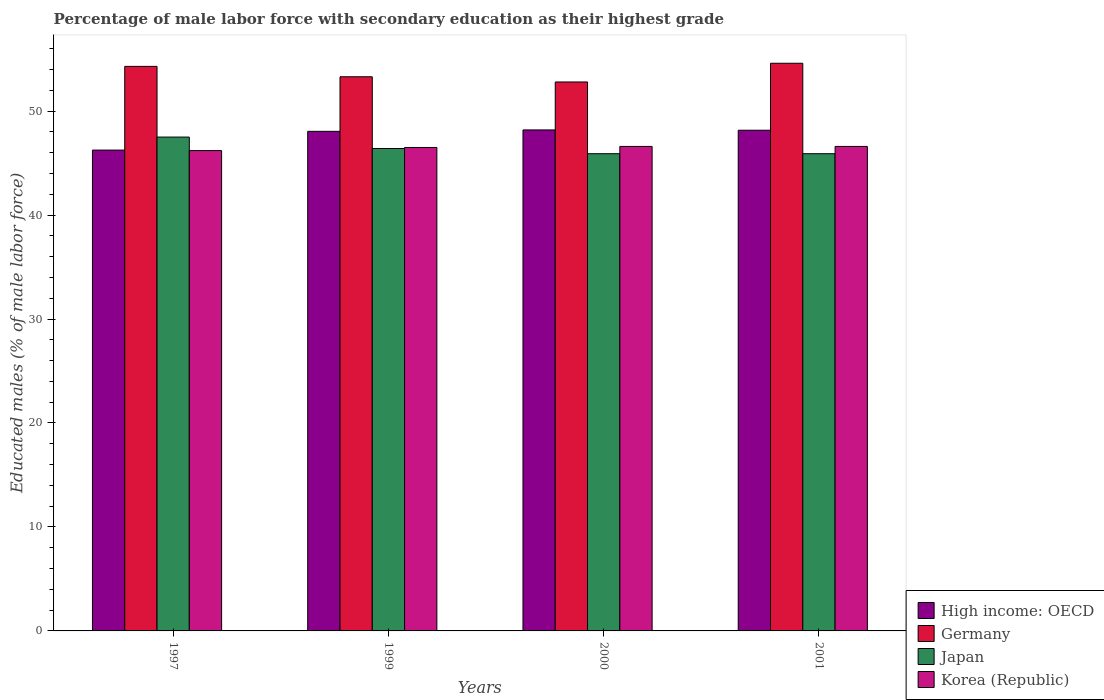How many groups of bars are there?
Your response must be concise. 4. How many bars are there on the 4th tick from the right?
Ensure brevity in your answer.  4. What is the label of the 3rd group of bars from the left?
Provide a succinct answer. 2000. What is the percentage of male labor force with secondary education in High income: OECD in 1999?
Give a very brief answer. 48.05. Across all years, what is the maximum percentage of male labor force with secondary education in Japan?
Offer a terse response. 47.5. Across all years, what is the minimum percentage of male labor force with secondary education in Germany?
Your response must be concise. 52.8. In which year was the percentage of male labor force with secondary education in Japan minimum?
Keep it short and to the point. 2000. What is the total percentage of male labor force with secondary education in High income: OECD in the graph?
Ensure brevity in your answer.  190.65. What is the difference between the percentage of male labor force with secondary education in Korea (Republic) in 1997 and that in 1999?
Give a very brief answer. -0.3. What is the difference between the percentage of male labor force with secondary education in High income: OECD in 2000 and the percentage of male labor force with secondary education in Korea (Republic) in 1999?
Keep it short and to the point. 1.69. What is the average percentage of male labor force with secondary education in Korea (Republic) per year?
Offer a very short reply. 46.47. In the year 2001, what is the difference between the percentage of male labor force with secondary education in Korea (Republic) and percentage of male labor force with secondary education in Japan?
Offer a very short reply. 0.7. What is the ratio of the percentage of male labor force with secondary education in Japan in 1999 to that in 2001?
Keep it short and to the point. 1.01. Is the percentage of male labor force with secondary education in Korea (Republic) in 1997 less than that in 2001?
Provide a succinct answer. Yes. What is the difference between the highest and the second highest percentage of male labor force with secondary education in Japan?
Make the answer very short. 1.1. What is the difference between the highest and the lowest percentage of male labor force with secondary education in Germany?
Your response must be concise. 1.8. Is the sum of the percentage of male labor force with secondary education in Germany in 1997 and 1999 greater than the maximum percentage of male labor force with secondary education in Korea (Republic) across all years?
Keep it short and to the point. Yes. Is it the case that in every year, the sum of the percentage of male labor force with secondary education in High income: OECD and percentage of male labor force with secondary education in Germany is greater than the sum of percentage of male labor force with secondary education in Korea (Republic) and percentage of male labor force with secondary education in Japan?
Give a very brief answer. Yes. What does the 2nd bar from the right in 1999 represents?
Offer a terse response. Japan. How many bars are there?
Ensure brevity in your answer.  16. Are all the bars in the graph horizontal?
Make the answer very short. No. What is the difference between two consecutive major ticks on the Y-axis?
Make the answer very short. 10. Are the values on the major ticks of Y-axis written in scientific E-notation?
Provide a succinct answer. No. Does the graph contain any zero values?
Give a very brief answer. No. Does the graph contain grids?
Your response must be concise. No. Where does the legend appear in the graph?
Ensure brevity in your answer.  Bottom right. How many legend labels are there?
Keep it short and to the point. 4. What is the title of the graph?
Make the answer very short. Percentage of male labor force with secondary education as their highest grade. Does "Kosovo" appear as one of the legend labels in the graph?
Keep it short and to the point. No. What is the label or title of the X-axis?
Your answer should be very brief. Years. What is the label or title of the Y-axis?
Give a very brief answer. Educated males (% of male labor force). What is the Educated males (% of male labor force) in High income: OECD in 1997?
Your answer should be very brief. 46.25. What is the Educated males (% of male labor force) of Germany in 1997?
Your answer should be compact. 54.3. What is the Educated males (% of male labor force) in Japan in 1997?
Ensure brevity in your answer.  47.5. What is the Educated males (% of male labor force) of Korea (Republic) in 1997?
Your answer should be very brief. 46.2. What is the Educated males (% of male labor force) of High income: OECD in 1999?
Ensure brevity in your answer.  48.05. What is the Educated males (% of male labor force) of Germany in 1999?
Provide a succinct answer. 53.3. What is the Educated males (% of male labor force) in Japan in 1999?
Your answer should be very brief. 46.4. What is the Educated males (% of male labor force) of Korea (Republic) in 1999?
Your answer should be very brief. 46.5. What is the Educated males (% of male labor force) in High income: OECD in 2000?
Offer a very short reply. 48.19. What is the Educated males (% of male labor force) in Germany in 2000?
Give a very brief answer. 52.8. What is the Educated males (% of male labor force) of Japan in 2000?
Provide a succinct answer. 45.9. What is the Educated males (% of male labor force) in Korea (Republic) in 2000?
Provide a succinct answer. 46.6. What is the Educated males (% of male labor force) of High income: OECD in 2001?
Make the answer very short. 48.16. What is the Educated males (% of male labor force) of Germany in 2001?
Make the answer very short. 54.6. What is the Educated males (% of male labor force) of Japan in 2001?
Keep it short and to the point. 45.9. What is the Educated males (% of male labor force) in Korea (Republic) in 2001?
Offer a terse response. 46.6. Across all years, what is the maximum Educated males (% of male labor force) in High income: OECD?
Provide a short and direct response. 48.19. Across all years, what is the maximum Educated males (% of male labor force) of Germany?
Your answer should be very brief. 54.6. Across all years, what is the maximum Educated males (% of male labor force) in Japan?
Keep it short and to the point. 47.5. Across all years, what is the maximum Educated males (% of male labor force) in Korea (Republic)?
Provide a short and direct response. 46.6. Across all years, what is the minimum Educated males (% of male labor force) in High income: OECD?
Your answer should be compact. 46.25. Across all years, what is the minimum Educated males (% of male labor force) in Germany?
Your answer should be compact. 52.8. Across all years, what is the minimum Educated males (% of male labor force) in Japan?
Ensure brevity in your answer.  45.9. Across all years, what is the minimum Educated males (% of male labor force) of Korea (Republic)?
Your answer should be very brief. 46.2. What is the total Educated males (% of male labor force) of High income: OECD in the graph?
Ensure brevity in your answer.  190.65. What is the total Educated males (% of male labor force) of Germany in the graph?
Keep it short and to the point. 215. What is the total Educated males (% of male labor force) in Japan in the graph?
Your answer should be very brief. 185.7. What is the total Educated males (% of male labor force) of Korea (Republic) in the graph?
Your answer should be very brief. 185.9. What is the difference between the Educated males (% of male labor force) of High income: OECD in 1997 and that in 1999?
Offer a terse response. -1.8. What is the difference between the Educated males (% of male labor force) of Japan in 1997 and that in 1999?
Give a very brief answer. 1.1. What is the difference between the Educated males (% of male labor force) of Korea (Republic) in 1997 and that in 1999?
Your response must be concise. -0.3. What is the difference between the Educated males (% of male labor force) of High income: OECD in 1997 and that in 2000?
Your answer should be very brief. -1.94. What is the difference between the Educated males (% of male labor force) of Korea (Republic) in 1997 and that in 2000?
Give a very brief answer. -0.4. What is the difference between the Educated males (% of male labor force) in High income: OECD in 1997 and that in 2001?
Make the answer very short. -1.91. What is the difference between the Educated males (% of male labor force) in Japan in 1997 and that in 2001?
Provide a short and direct response. 1.6. What is the difference between the Educated males (% of male labor force) in Korea (Republic) in 1997 and that in 2001?
Offer a terse response. -0.4. What is the difference between the Educated males (% of male labor force) in High income: OECD in 1999 and that in 2000?
Your answer should be very brief. -0.14. What is the difference between the Educated males (% of male labor force) of High income: OECD in 1999 and that in 2001?
Your answer should be very brief. -0.11. What is the difference between the Educated males (% of male labor force) in High income: OECD in 2000 and that in 2001?
Ensure brevity in your answer.  0.03. What is the difference between the Educated males (% of male labor force) of Germany in 2000 and that in 2001?
Ensure brevity in your answer.  -1.8. What is the difference between the Educated males (% of male labor force) of High income: OECD in 1997 and the Educated males (% of male labor force) of Germany in 1999?
Your answer should be very brief. -7.05. What is the difference between the Educated males (% of male labor force) in High income: OECD in 1997 and the Educated males (% of male labor force) in Japan in 1999?
Keep it short and to the point. -0.15. What is the difference between the Educated males (% of male labor force) in High income: OECD in 1997 and the Educated males (% of male labor force) in Korea (Republic) in 1999?
Your response must be concise. -0.25. What is the difference between the Educated males (% of male labor force) in Germany in 1997 and the Educated males (% of male labor force) in Korea (Republic) in 1999?
Ensure brevity in your answer.  7.8. What is the difference between the Educated males (% of male labor force) in Japan in 1997 and the Educated males (% of male labor force) in Korea (Republic) in 1999?
Make the answer very short. 1. What is the difference between the Educated males (% of male labor force) in High income: OECD in 1997 and the Educated males (% of male labor force) in Germany in 2000?
Your response must be concise. -6.55. What is the difference between the Educated males (% of male labor force) of High income: OECD in 1997 and the Educated males (% of male labor force) of Japan in 2000?
Your response must be concise. 0.35. What is the difference between the Educated males (% of male labor force) of High income: OECD in 1997 and the Educated males (% of male labor force) of Korea (Republic) in 2000?
Offer a terse response. -0.35. What is the difference between the Educated males (% of male labor force) in Germany in 1997 and the Educated males (% of male labor force) in Japan in 2000?
Provide a succinct answer. 8.4. What is the difference between the Educated males (% of male labor force) in Japan in 1997 and the Educated males (% of male labor force) in Korea (Republic) in 2000?
Your response must be concise. 0.9. What is the difference between the Educated males (% of male labor force) of High income: OECD in 1997 and the Educated males (% of male labor force) of Germany in 2001?
Keep it short and to the point. -8.35. What is the difference between the Educated males (% of male labor force) of High income: OECD in 1997 and the Educated males (% of male labor force) of Japan in 2001?
Provide a short and direct response. 0.35. What is the difference between the Educated males (% of male labor force) of High income: OECD in 1997 and the Educated males (% of male labor force) of Korea (Republic) in 2001?
Your answer should be compact. -0.35. What is the difference between the Educated males (% of male labor force) of Germany in 1997 and the Educated males (% of male labor force) of Korea (Republic) in 2001?
Provide a short and direct response. 7.7. What is the difference between the Educated males (% of male labor force) in Japan in 1997 and the Educated males (% of male labor force) in Korea (Republic) in 2001?
Make the answer very short. 0.9. What is the difference between the Educated males (% of male labor force) in High income: OECD in 1999 and the Educated males (% of male labor force) in Germany in 2000?
Offer a very short reply. -4.75. What is the difference between the Educated males (% of male labor force) in High income: OECD in 1999 and the Educated males (% of male labor force) in Japan in 2000?
Keep it short and to the point. 2.15. What is the difference between the Educated males (% of male labor force) of High income: OECD in 1999 and the Educated males (% of male labor force) of Korea (Republic) in 2000?
Offer a terse response. 1.45. What is the difference between the Educated males (% of male labor force) in High income: OECD in 1999 and the Educated males (% of male labor force) in Germany in 2001?
Give a very brief answer. -6.55. What is the difference between the Educated males (% of male labor force) in High income: OECD in 1999 and the Educated males (% of male labor force) in Japan in 2001?
Your answer should be compact. 2.15. What is the difference between the Educated males (% of male labor force) in High income: OECD in 1999 and the Educated males (% of male labor force) in Korea (Republic) in 2001?
Your answer should be very brief. 1.45. What is the difference between the Educated males (% of male labor force) of Germany in 1999 and the Educated males (% of male labor force) of Japan in 2001?
Offer a terse response. 7.4. What is the difference between the Educated males (% of male labor force) of Germany in 1999 and the Educated males (% of male labor force) of Korea (Republic) in 2001?
Give a very brief answer. 6.7. What is the difference between the Educated males (% of male labor force) in Japan in 1999 and the Educated males (% of male labor force) in Korea (Republic) in 2001?
Offer a terse response. -0.2. What is the difference between the Educated males (% of male labor force) of High income: OECD in 2000 and the Educated males (% of male labor force) of Germany in 2001?
Offer a very short reply. -6.41. What is the difference between the Educated males (% of male labor force) in High income: OECD in 2000 and the Educated males (% of male labor force) in Japan in 2001?
Ensure brevity in your answer.  2.29. What is the difference between the Educated males (% of male labor force) in High income: OECD in 2000 and the Educated males (% of male labor force) in Korea (Republic) in 2001?
Give a very brief answer. 1.59. What is the difference between the Educated males (% of male labor force) in Germany in 2000 and the Educated males (% of male labor force) in Korea (Republic) in 2001?
Make the answer very short. 6.2. What is the difference between the Educated males (% of male labor force) of Japan in 2000 and the Educated males (% of male labor force) of Korea (Republic) in 2001?
Ensure brevity in your answer.  -0.7. What is the average Educated males (% of male labor force) in High income: OECD per year?
Give a very brief answer. 47.66. What is the average Educated males (% of male labor force) in Germany per year?
Make the answer very short. 53.75. What is the average Educated males (% of male labor force) in Japan per year?
Make the answer very short. 46.42. What is the average Educated males (% of male labor force) of Korea (Republic) per year?
Ensure brevity in your answer.  46.48. In the year 1997, what is the difference between the Educated males (% of male labor force) of High income: OECD and Educated males (% of male labor force) of Germany?
Provide a short and direct response. -8.05. In the year 1997, what is the difference between the Educated males (% of male labor force) in High income: OECD and Educated males (% of male labor force) in Japan?
Provide a succinct answer. -1.25. In the year 1997, what is the difference between the Educated males (% of male labor force) in High income: OECD and Educated males (% of male labor force) in Korea (Republic)?
Your response must be concise. 0.05. In the year 1999, what is the difference between the Educated males (% of male labor force) in High income: OECD and Educated males (% of male labor force) in Germany?
Give a very brief answer. -5.25. In the year 1999, what is the difference between the Educated males (% of male labor force) in High income: OECD and Educated males (% of male labor force) in Japan?
Your response must be concise. 1.65. In the year 1999, what is the difference between the Educated males (% of male labor force) of High income: OECD and Educated males (% of male labor force) of Korea (Republic)?
Give a very brief answer. 1.55. In the year 2000, what is the difference between the Educated males (% of male labor force) of High income: OECD and Educated males (% of male labor force) of Germany?
Make the answer very short. -4.61. In the year 2000, what is the difference between the Educated males (% of male labor force) of High income: OECD and Educated males (% of male labor force) of Japan?
Provide a short and direct response. 2.29. In the year 2000, what is the difference between the Educated males (% of male labor force) of High income: OECD and Educated males (% of male labor force) of Korea (Republic)?
Your answer should be compact. 1.59. In the year 2000, what is the difference between the Educated males (% of male labor force) of Germany and Educated males (% of male labor force) of Korea (Republic)?
Provide a succinct answer. 6.2. In the year 2000, what is the difference between the Educated males (% of male labor force) of Japan and Educated males (% of male labor force) of Korea (Republic)?
Give a very brief answer. -0.7. In the year 2001, what is the difference between the Educated males (% of male labor force) in High income: OECD and Educated males (% of male labor force) in Germany?
Offer a terse response. -6.44. In the year 2001, what is the difference between the Educated males (% of male labor force) in High income: OECD and Educated males (% of male labor force) in Japan?
Offer a terse response. 2.26. In the year 2001, what is the difference between the Educated males (% of male labor force) of High income: OECD and Educated males (% of male labor force) of Korea (Republic)?
Ensure brevity in your answer.  1.56. In the year 2001, what is the difference between the Educated males (% of male labor force) of Germany and Educated males (% of male labor force) of Japan?
Offer a terse response. 8.7. In the year 2001, what is the difference between the Educated males (% of male labor force) of Japan and Educated males (% of male labor force) of Korea (Republic)?
Give a very brief answer. -0.7. What is the ratio of the Educated males (% of male labor force) in High income: OECD in 1997 to that in 1999?
Offer a terse response. 0.96. What is the ratio of the Educated males (% of male labor force) of Germany in 1997 to that in 1999?
Provide a short and direct response. 1.02. What is the ratio of the Educated males (% of male labor force) in Japan in 1997 to that in 1999?
Your answer should be compact. 1.02. What is the ratio of the Educated males (% of male labor force) of High income: OECD in 1997 to that in 2000?
Make the answer very short. 0.96. What is the ratio of the Educated males (% of male labor force) in Germany in 1997 to that in 2000?
Make the answer very short. 1.03. What is the ratio of the Educated males (% of male labor force) of Japan in 1997 to that in 2000?
Ensure brevity in your answer.  1.03. What is the ratio of the Educated males (% of male labor force) in High income: OECD in 1997 to that in 2001?
Give a very brief answer. 0.96. What is the ratio of the Educated males (% of male labor force) of Germany in 1997 to that in 2001?
Give a very brief answer. 0.99. What is the ratio of the Educated males (% of male labor force) of Japan in 1997 to that in 2001?
Keep it short and to the point. 1.03. What is the ratio of the Educated males (% of male labor force) of Korea (Republic) in 1997 to that in 2001?
Provide a succinct answer. 0.99. What is the ratio of the Educated males (% of male labor force) in High income: OECD in 1999 to that in 2000?
Your answer should be very brief. 1. What is the ratio of the Educated males (% of male labor force) of Germany in 1999 to that in 2000?
Your response must be concise. 1.01. What is the ratio of the Educated males (% of male labor force) in Japan in 1999 to that in 2000?
Your response must be concise. 1.01. What is the ratio of the Educated males (% of male labor force) of Germany in 1999 to that in 2001?
Your answer should be compact. 0.98. What is the ratio of the Educated males (% of male labor force) of Japan in 1999 to that in 2001?
Your answer should be very brief. 1.01. What is the ratio of the Educated males (% of male labor force) of High income: OECD in 2000 to that in 2001?
Provide a succinct answer. 1. What is the ratio of the Educated males (% of male labor force) in Korea (Republic) in 2000 to that in 2001?
Ensure brevity in your answer.  1. What is the difference between the highest and the second highest Educated males (% of male labor force) of High income: OECD?
Your answer should be compact. 0.03. What is the difference between the highest and the second highest Educated males (% of male labor force) in Japan?
Make the answer very short. 1.1. What is the difference between the highest and the lowest Educated males (% of male labor force) in High income: OECD?
Make the answer very short. 1.94. What is the difference between the highest and the lowest Educated males (% of male labor force) of Japan?
Your response must be concise. 1.6. 